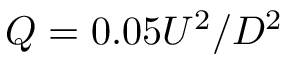Convert formula to latex. <formula><loc_0><loc_0><loc_500><loc_500>Q = 0 . 0 5 U ^ { 2 } / D ^ { 2 }</formula> 